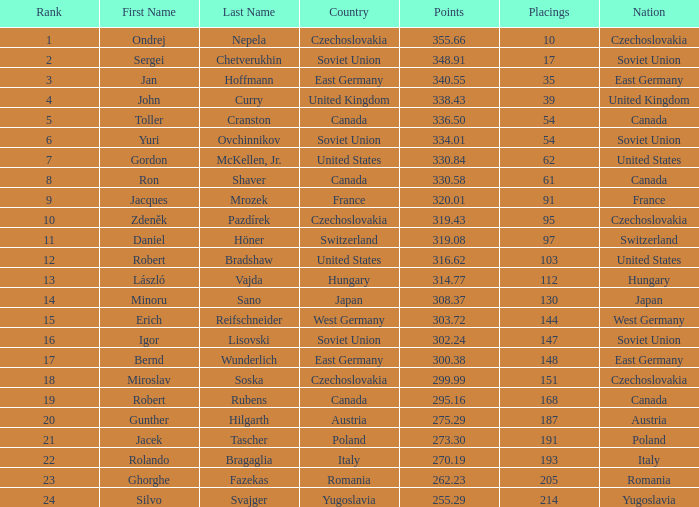38 points? East Germany. 